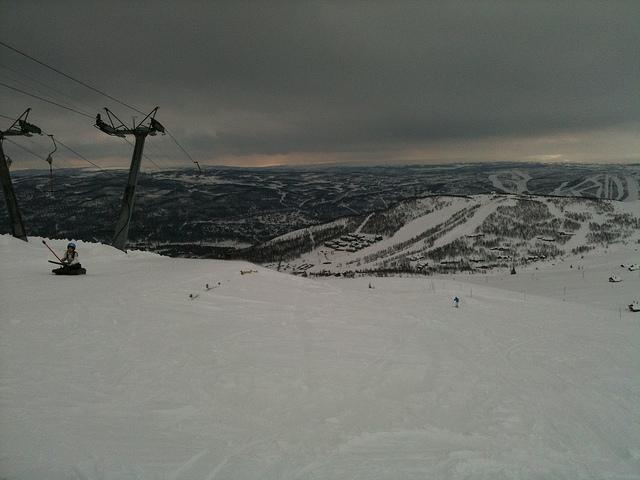What are the overhead cables for? ski lift 